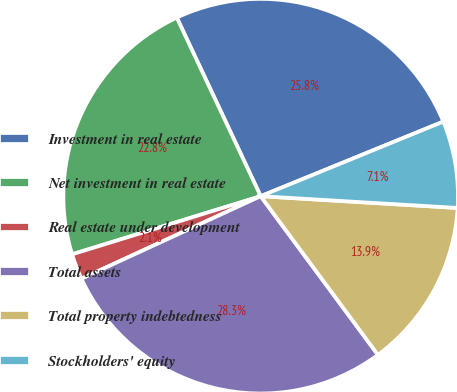<chart> <loc_0><loc_0><loc_500><loc_500><pie_chart><fcel>Investment in real estate<fcel>Net investment in real estate<fcel>Real estate under development<fcel>Total assets<fcel>Total property indebtedness<fcel>Stockholders' equity<nl><fcel>25.82%<fcel>22.77%<fcel>2.11%<fcel>28.26%<fcel>13.92%<fcel>7.12%<nl></chart> 